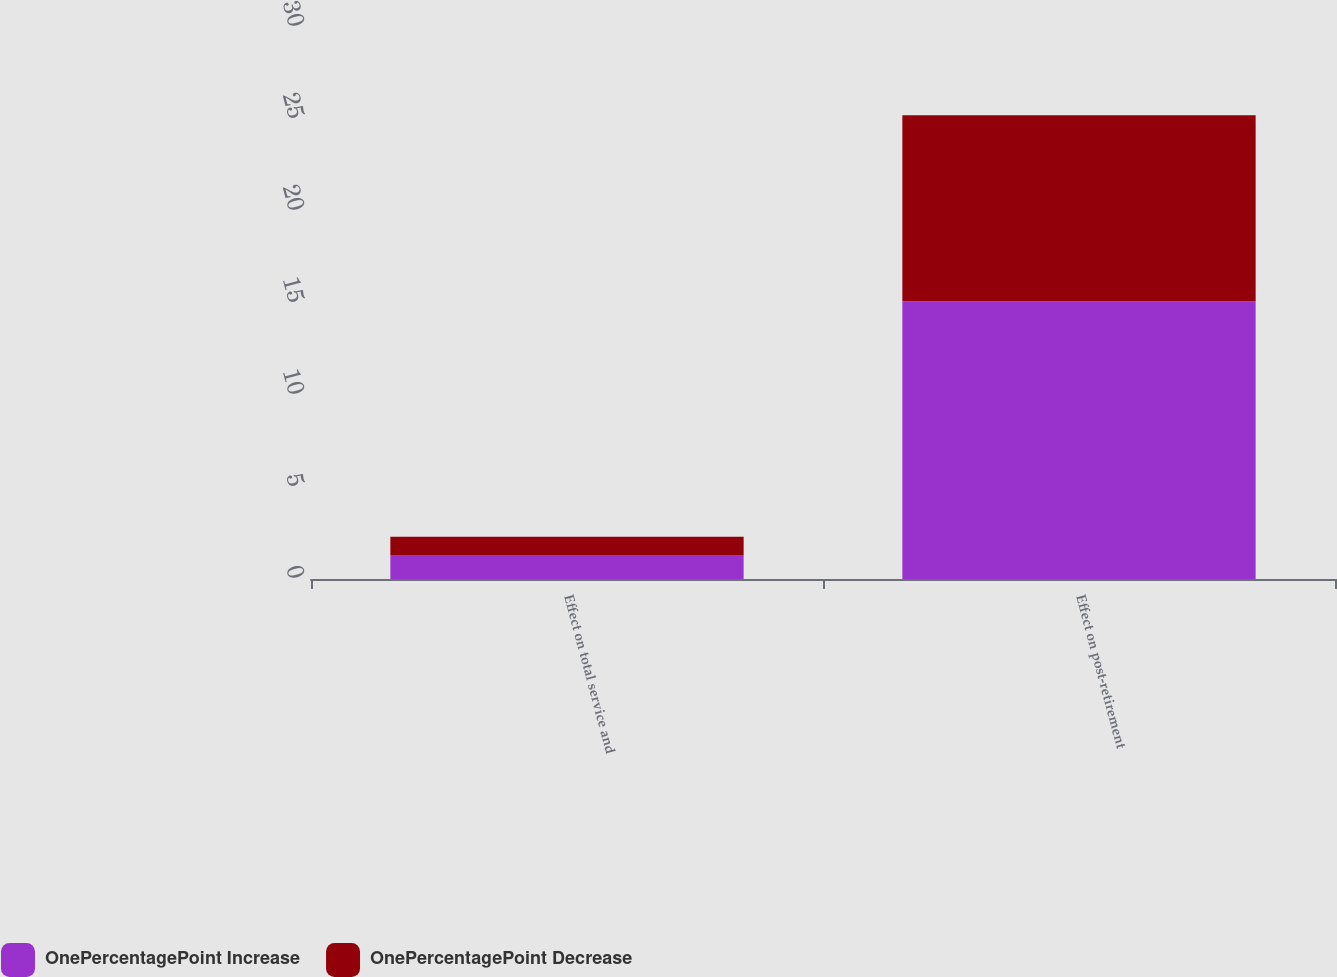Convert chart to OTSL. <chart><loc_0><loc_0><loc_500><loc_500><stacked_bar_chart><ecel><fcel>Effect on total service and<fcel>Effect on post-retirement<nl><fcel>OnePercentagePoint Increase<fcel>1.3<fcel>15.1<nl><fcel>OnePercentagePoint Decrease<fcel>1<fcel>10.1<nl></chart> 